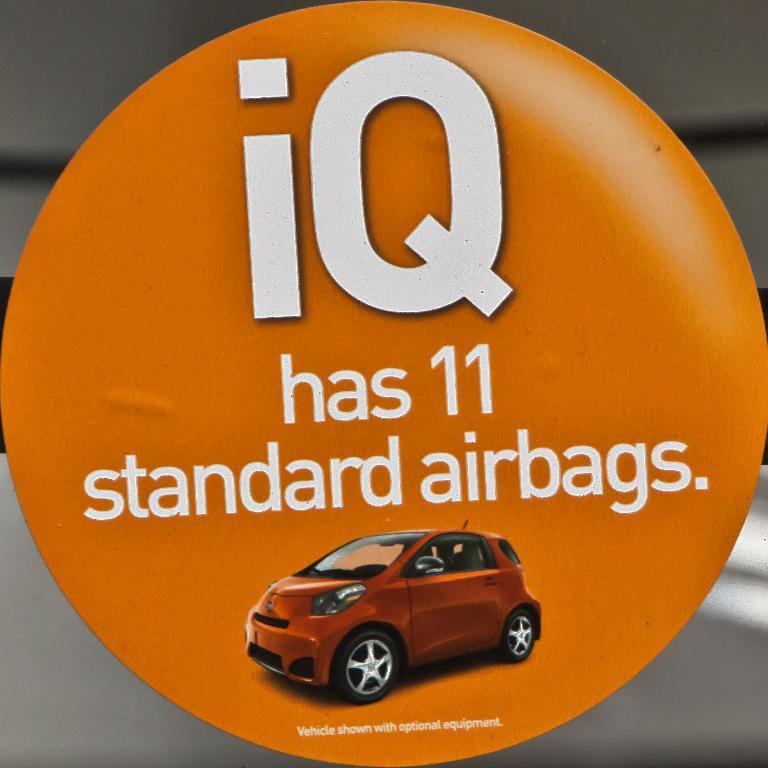What can be found in the image that contains written information? There is written text in the image. What type of vehicle is present in the image? There is a car in the image. What color is the background of the image? The background of the image is orange. What health benefits can be gained from the car in the image? There are no health benefits associated with the car in the image, as it is a vehicle and not a source of health information or products. Is the image taken during the winter season? The provided facts do not mention any seasonal context, so it cannot be determined if the image was taken during winter. 